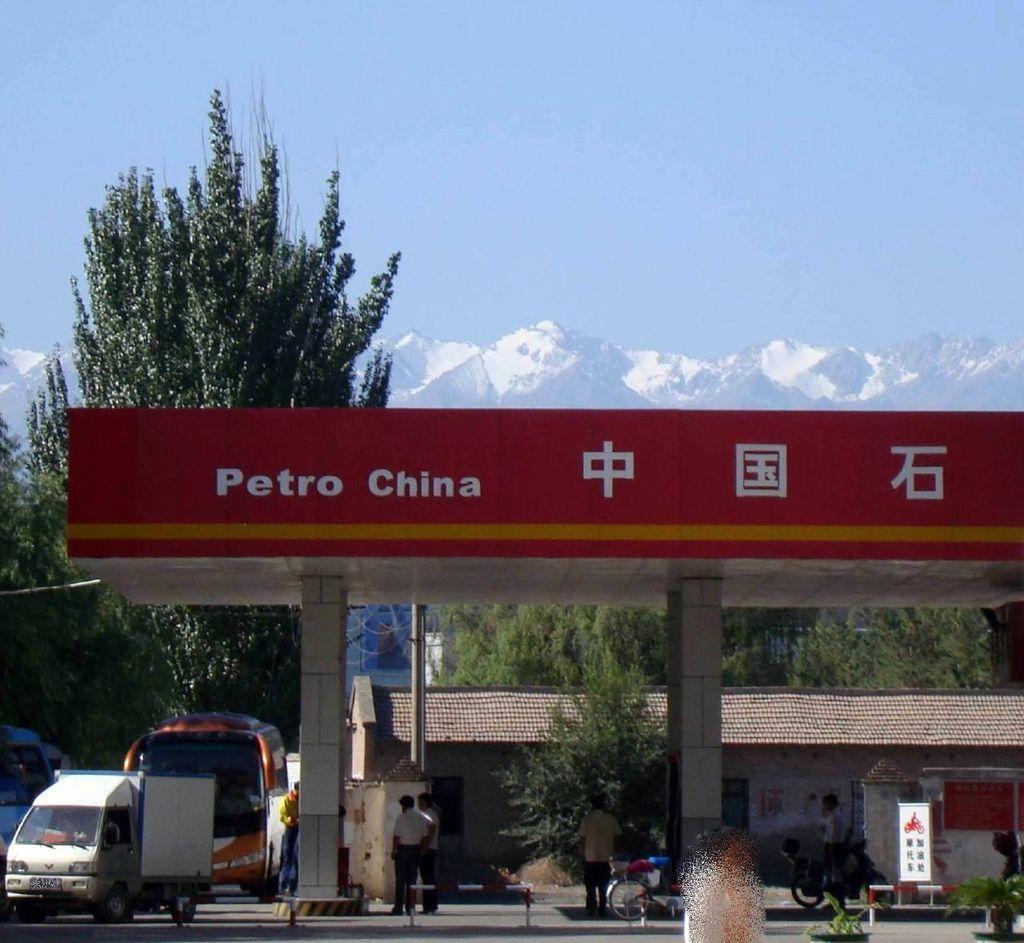Could you give a brief overview of what you see in this image? In this picture we can observe a petrol filling station. There are some vehicles. We can observe trees and plants. There is a house here. In the background we can observe some mountains and a sky. 